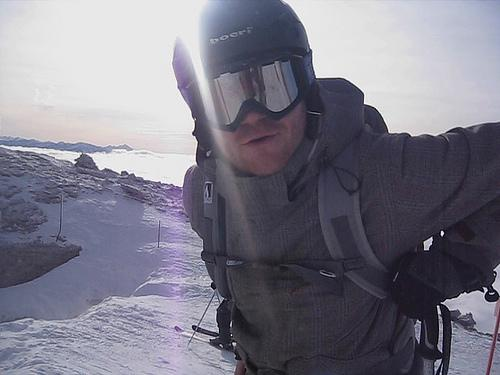What nationality were the founders of this helmet company? Please explain your reasoning. italian. The nationality is italian. 